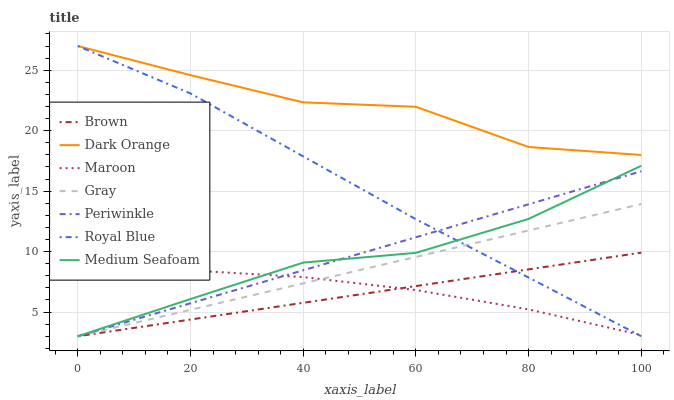Does Brown have the minimum area under the curve?
Answer yes or no. Yes. Does Dark Orange have the maximum area under the curve?
Answer yes or no. Yes. Does Gray have the minimum area under the curve?
Answer yes or no. No. Does Gray have the maximum area under the curve?
Answer yes or no. No. Is Gray the smoothest?
Answer yes or no. Yes. Is Dark Orange the roughest?
Answer yes or no. Yes. Is Maroon the smoothest?
Answer yes or no. No. Is Maroon the roughest?
Answer yes or no. No. Does Brown have the lowest value?
Answer yes or no. Yes. Does Maroon have the lowest value?
Answer yes or no. No. Does Royal Blue have the highest value?
Answer yes or no. Yes. Does Gray have the highest value?
Answer yes or no. No. Is Maroon less than Dark Orange?
Answer yes or no. Yes. Is Dark Orange greater than Brown?
Answer yes or no. Yes. Does Brown intersect Maroon?
Answer yes or no. Yes. Is Brown less than Maroon?
Answer yes or no. No. Is Brown greater than Maroon?
Answer yes or no. No. Does Maroon intersect Dark Orange?
Answer yes or no. No. 